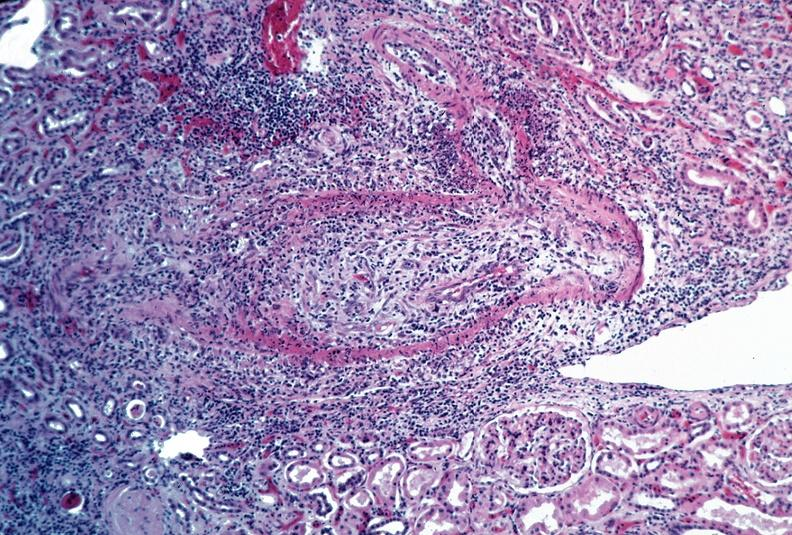where is this from?
Answer the question using a single word or phrase. Vasculature 